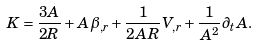<formula> <loc_0><loc_0><loc_500><loc_500>K = \frac { 3 A } { 2 R } + A \beta _ { , r } + \frac { 1 } { 2 A R } V _ { , r } + \frac { 1 } { A ^ { 2 } } \partial _ { t } A .</formula> 